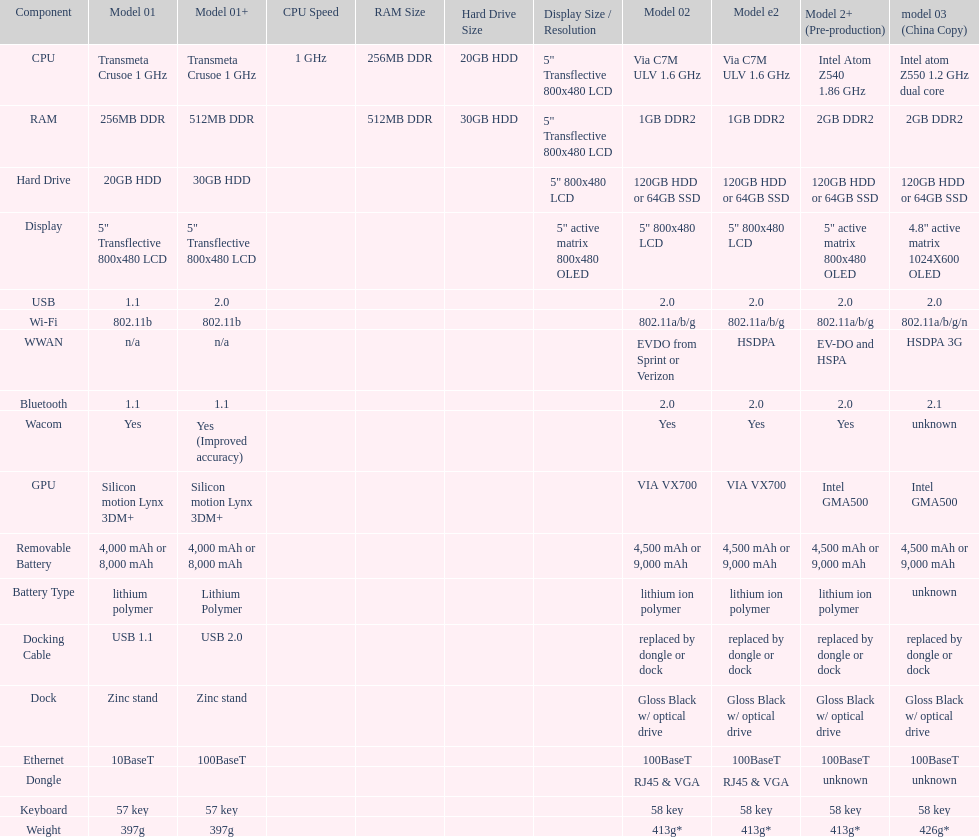How many models have 1.6ghz? 2. Could you parse the entire table? {'header': ['Component', 'Model 01', 'Model 01+', 'CPU Speed', 'RAM Size', 'Hard Drive Size', 'Display Size / Resolution', 'Model 02', 'Model e2', 'Model 2+ (Pre-production)', 'model 03 (China Copy)'], 'rows': [['CPU', 'Transmeta Crusoe 1\xa0GHz', 'Transmeta Crusoe 1\xa0GHz', '1\xa0GHz', '256MB DDR', '20GB HDD', '5" Transflective 800x480 LCD', 'Via C7M ULV 1.6\xa0GHz', 'Via C7M ULV 1.6\xa0GHz', 'Intel Atom Z540 1.86\xa0GHz', 'Intel atom Z550 1.2\xa0GHz dual core'], ['RAM', '256MB DDR', '512MB DDR', '', '512MB DDR', '30GB HDD', '5" Transflective 800x480 LCD', '1GB DDR2', '1GB DDR2', '2GB DDR2', '2GB DDR2'], ['Hard Drive', '20GB HDD', '30GB HDD', '', '', '', '5" 800x480 LCD', '120GB HDD or 64GB SSD', '120GB HDD or 64GB SSD', '120GB HDD or 64GB SSD', '120GB HDD or 64GB SSD'], ['Display', '5" Transflective 800x480 LCD', '5" Transflective 800x480 LCD', '', '', '', '5" active matrix 800x480 OLED', '5" 800x480 LCD', '5" 800x480 LCD', '5" active matrix 800x480 OLED', '4.8" active matrix 1024X600 OLED'], ['USB', '1.1', '2.0', '', '', '', '', '2.0', '2.0', '2.0', '2.0'], ['Wi-Fi', '802.11b', '802.11b', '', '', '', '', '802.11a/b/g', '802.11a/b/g', '802.11a/b/g', '802.11a/b/g/n'], ['WWAN', 'n/a', 'n/a', '', '', '', '', 'EVDO from Sprint or Verizon', 'HSDPA', 'EV-DO and HSPA', 'HSDPA 3G'], ['Bluetooth', '1.1', '1.1', '', '', '', '', '2.0', '2.0', '2.0', '2.1'], ['Wacom', 'Yes', 'Yes (Improved accuracy)', '', '', '', '', 'Yes', 'Yes', 'Yes', 'unknown'], ['GPU', 'Silicon motion Lynx 3DM+', 'Silicon motion Lynx 3DM+', '', '', '', '', 'VIA VX700', 'VIA VX700', 'Intel GMA500', 'Intel GMA500'], ['Removable Battery', '4,000 mAh or 8,000 mAh', '4,000 mAh or 8,000 mAh', '', '', '', '', '4,500 mAh or 9,000 mAh', '4,500 mAh or 9,000 mAh', '4,500 mAh or 9,000 mAh', '4,500 mAh or 9,000 mAh'], ['Battery Type', 'lithium polymer', 'Lithium Polymer', '', '', '', '', 'lithium ion polymer', 'lithium ion polymer', 'lithium ion polymer', 'unknown'], ['Docking Cable', 'USB 1.1', 'USB 2.0', '', '', '', '', 'replaced by dongle or dock', 'replaced by dongle or dock', 'replaced by dongle or dock', 'replaced by dongle or dock'], ['Dock', 'Zinc stand', 'Zinc stand', '', '', '', '', 'Gloss Black w/ optical drive', 'Gloss Black w/ optical drive', 'Gloss Black w/ optical drive', 'Gloss Black w/ optical drive'], ['Ethernet', '10BaseT', '100BaseT', '', '', '', '', '100BaseT', '100BaseT', '100BaseT', '100BaseT'], ['Dongle', '', '', '', '', '', '', 'RJ45 & VGA', 'RJ45 & VGA', 'unknown', 'unknown'], ['Keyboard', '57 key', '57 key', '', '', '', '', '58 key', '58 key', '58 key', '58 key'], ['Weight', '397g', '397g', '', '', '', '', '413g*', '413g*', '413g*', '426g*']]} 